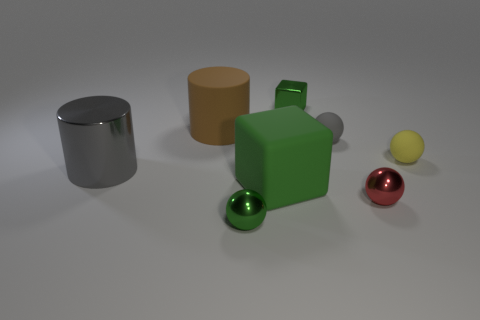The metallic object that is behind the yellow thing that is to the right of the rubber block is what shape? cube 